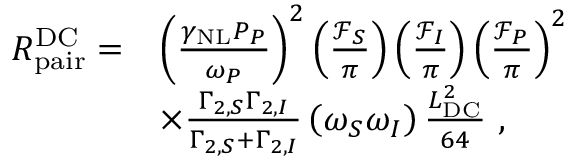Convert formula to latex. <formula><loc_0><loc_0><loc_500><loc_500>\begin{array} { r l } { R _ { p a i r } ^ { D C } = } & { \left ( \frac { \gamma _ { N L } P _ { P } } { \omega _ { P } } \right ) ^ { 2 } \left ( \frac { \mathcal { F } _ { S } } { \pi } \right ) \left ( \frac { \mathcal { F } _ { I } } { \pi } \right ) \left ( \frac { \mathcal { F } _ { P } } { \pi } \right ) ^ { 2 } } \\ & { \times \frac { \Gamma _ { 2 , S } \Gamma _ { 2 , I } } { \Gamma _ { 2 , S } + \Gamma _ { 2 , I } } \left ( \omega _ { S } \omega _ { I } \right ) \frac { L _ { D C } ^ { 2 } } { 6 4 } \ , } \end{array}</formula> 